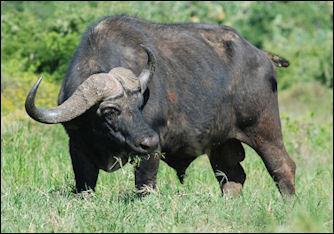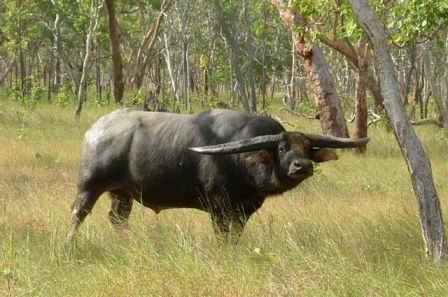The first image is the image on the left, the second image is the image on the right. Given the left and right images, does the statement "The water buffalo in the right image is facing towards the right." hold true? Answer yes or no. Yes. 